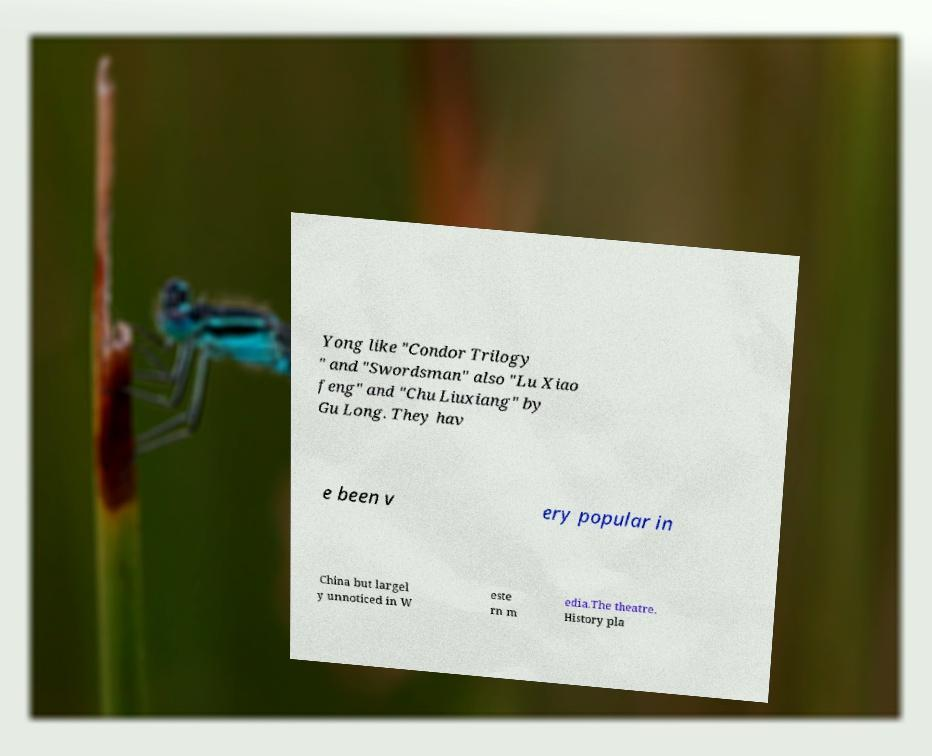Could you assist in decoding the text presented in this image and type it out clearly? Yong like "Condor Trilogy " and "Swordsman" also "Lu Xiao feng" and "Chu Liuxiang" by Gu Long. They hav e been v ery popular in China but largel y unnoticed in W este rn m edia.The theatre. History pla 